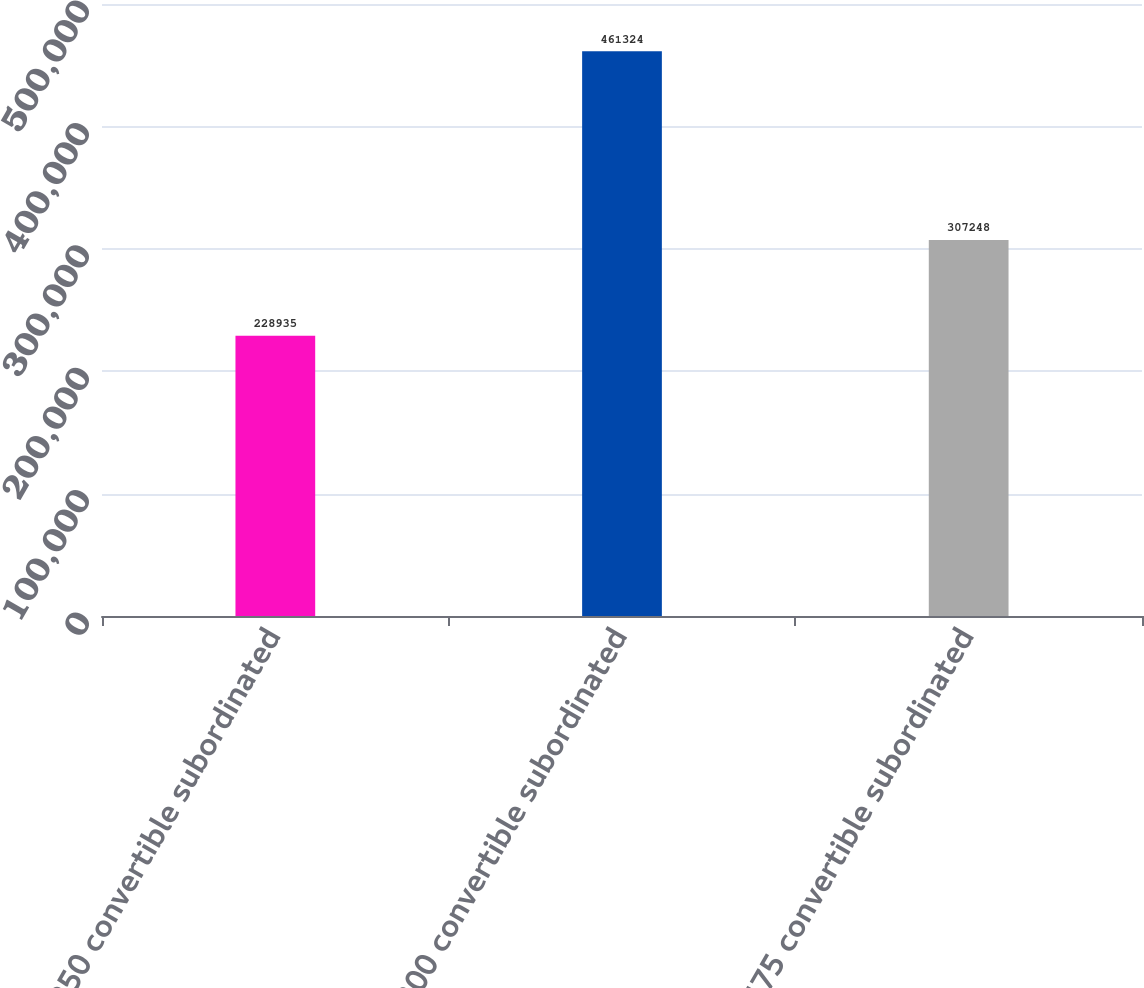Convert chart to OTSL. <chart><loc_0><loc_0><loc_500><loc_500><bar_chart><fcel>250 convertible subordinated<fcel>300 convertible subordinated<fcel>475 convertible subordinated<nl><fcel>228935<fcel>461324<fcel>307248<nl></chart> 